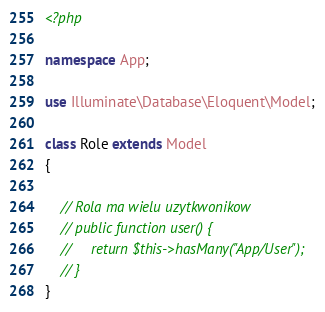Convert code to text. <code><loc_0><loc_0><loc_500><loc_500><_PHP_><?php

namespace App;

use Illuminate\Database\Eloquent\Model;

class Role extends Model
{
   
    // Rola ma wielu uzytkwonikow
    // public function user() { 
    //     return $this->hasMany("App/User");
    // }
}
</code> 